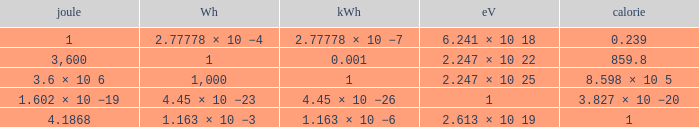How many electronvolts is 3,600 joules? 2.247 × 10 22. 